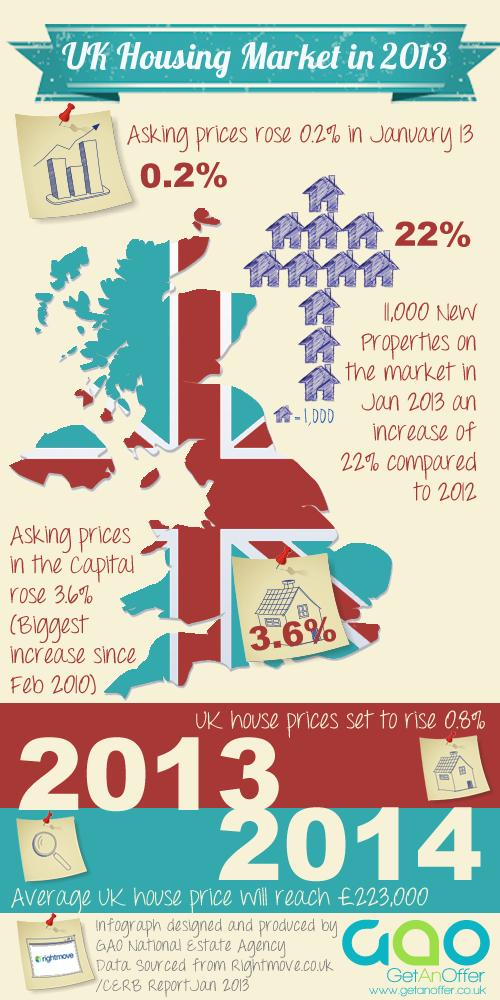Mention a couple of crucial points in this snapshot. The asking price of homes in the UK is expected to rise by 0.8% in 2013. The asking price in London rose significantly more, by 3.4%, when compared to the overall housing market in the UK. In 2013, there was a 22% increase in the number of new properties when compared to the previous year, 2012. 